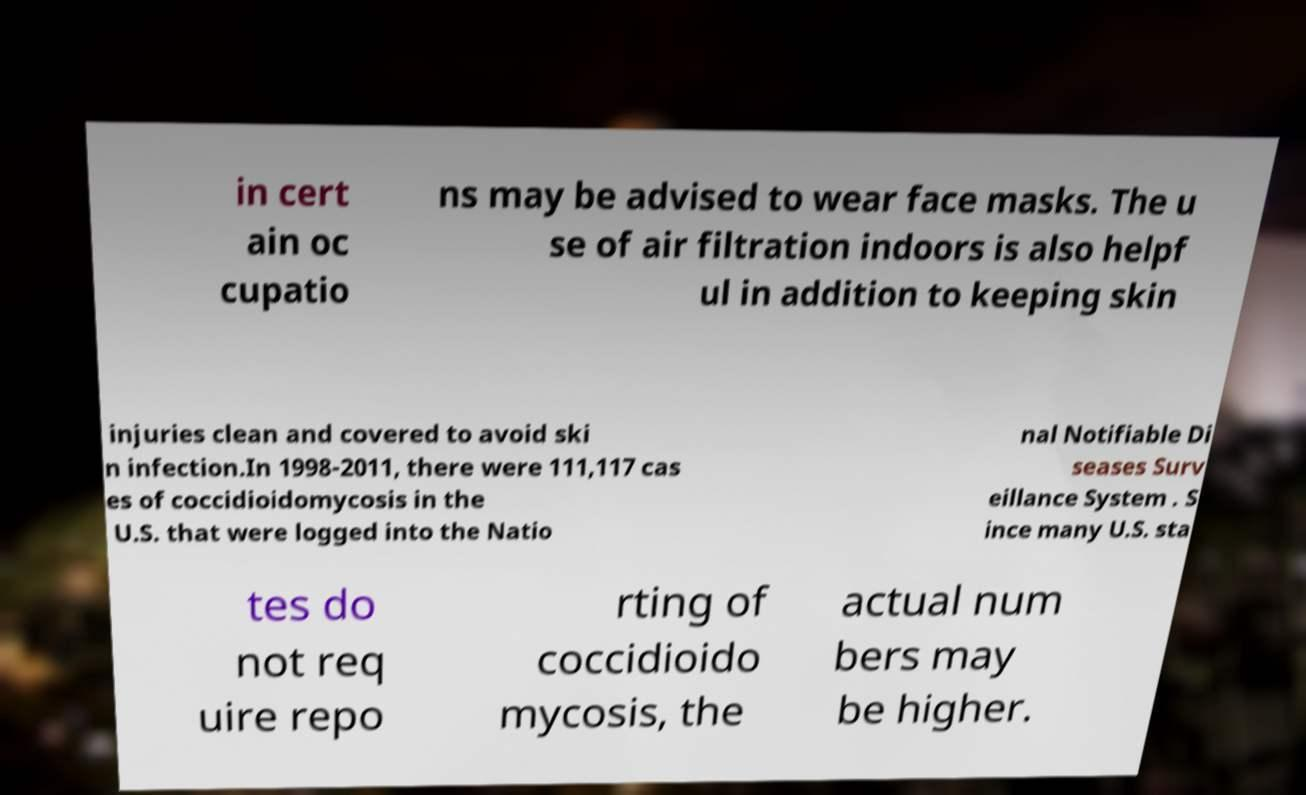Could you assist in decoding the text presented in this image and type it out clearly? in cert ain oc cupatio ns may be advised to wear face masks. The u se of air filtration indoors is also helpf ul in addition to keeping skin injuries clean and covered to avoid ski n infection.In 1998-2011, there were 111,117 cas es of coccidioidomycosis in the U.S. that were logged into the Natio nal Notifiable Di seases Surv eillance System . S ince many U.S. sta tes do not req uire repo rting of coccidioido mycosis, the actual num bers may be higher. 